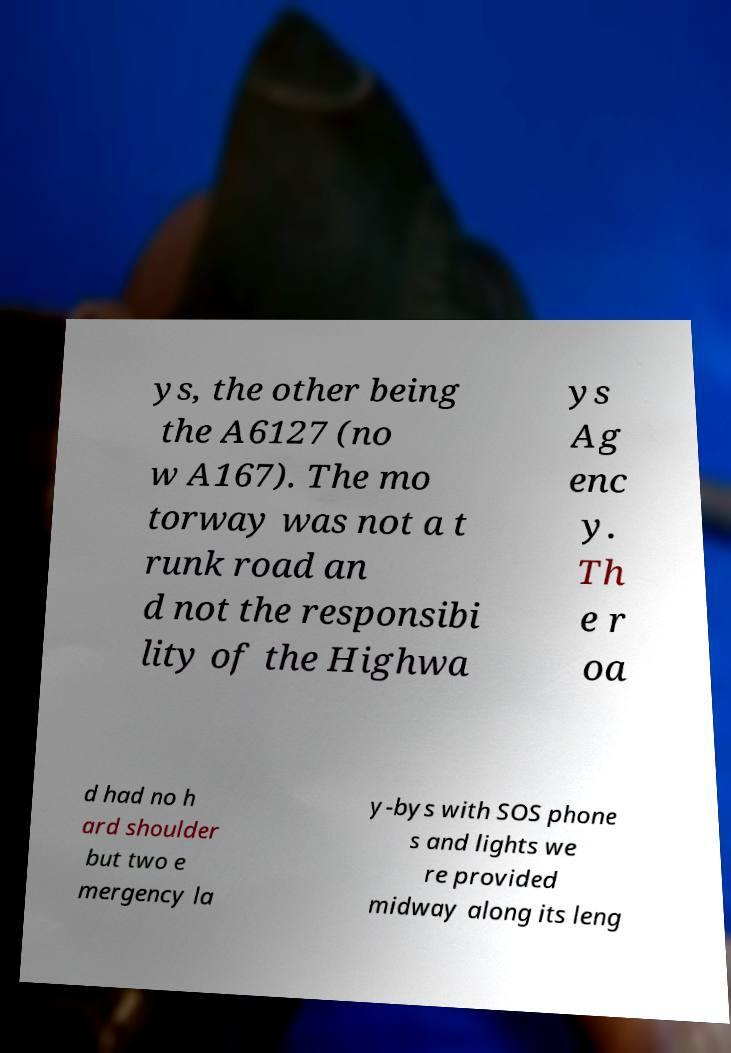Could you assist in decoding the text presented in this image and type it out clearly? ys, the other being the A6127 (no w A167). The mo torway was not a t runk road an d not the responsibi lity of the Highwa ys Ag enc y. Th e r oa d had no h ard shoulder but two e mergency la y-bys with SOS phone s and lights we re provided midway along its leng 